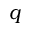Convert formula to latex. <formula><loc_0><loc_0><loc_500><loc_500>q</formula> 